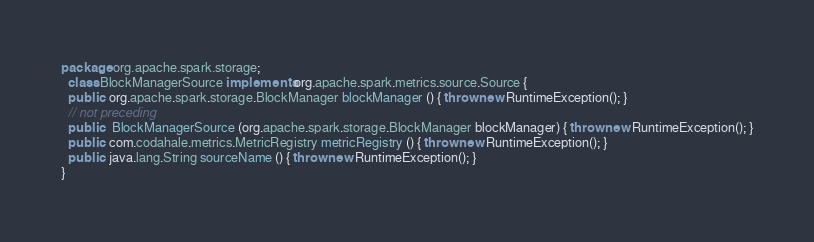<code> <loc_0><loc_0><loc_500><loc_500><_Java_>package org.apache.spark.storage;
  class BlockManagerSource implements org.apache.spark.metrics.source.Source {
  public  org.apache.spark.storage.BlockManager blockManager () { throw new RuntimeException(); }
  // not preceding
  public   BlockManagerSource (org.apache.spark.storage.BlockManager blockManager) { throw new RuntimeException(); }
  public  com.codahale.metrics.MetricRegistry metricRegistry () { throw new RuntimeException(); }
  public  java.lang.String sourceName () { throw new RuntimeException(); }
}
</code> 